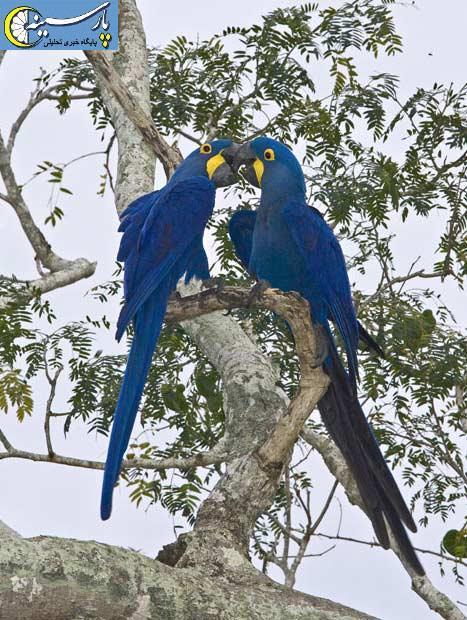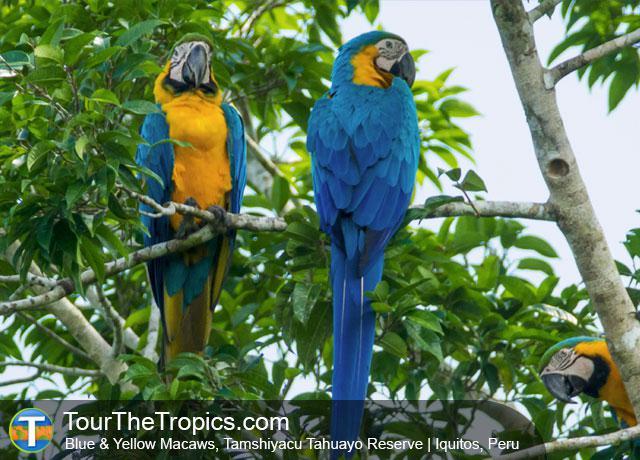The first image is the image on the left, the second image is the image on the right. Analyze the images presented: Is the assertion "One image includes a red-headed bird and a bird with blue-and-yellow coloring." valid? Answer yes or no. No. The first image is the image on the left, the second image is the image on the right. For the images displayed, is the sentence "Two blue birds are perched on a branch in the image on the left." factually correct? Answer yes or no. Yes. 